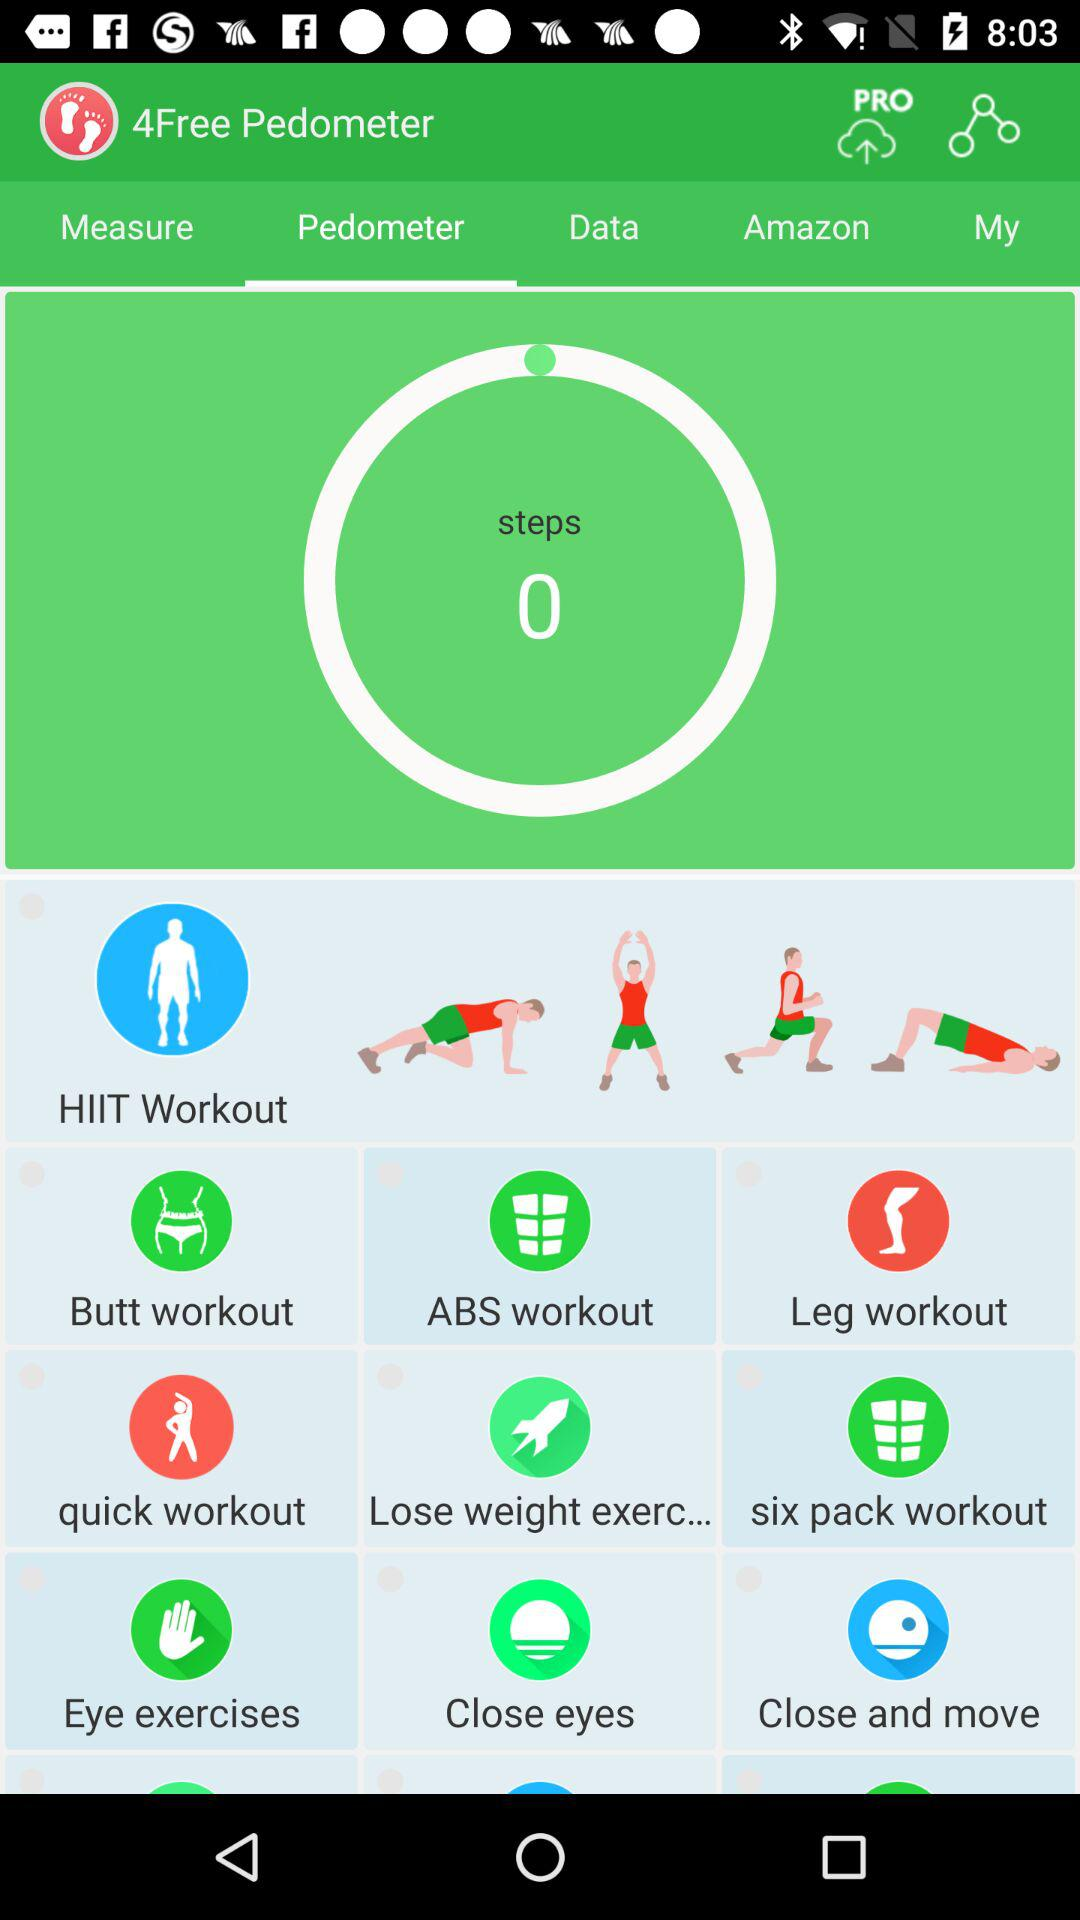What is the count of steps? The count of steps is 0. 